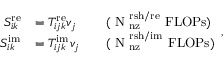<formula> <loc_0><loc_0><loc_500><loc_500>\begin{array} { r l r l } { S _ { i k } ^ { r e } } & { = T _ { i j k } ^ { r e } v _ { j } } & & { ( N _ { \mathrm } { n z } ^ { \mathrm } { r s h / r e } F L O P s ) } \\ { S _ { i k } ^ { i m } } & { = T _ { i j k } ^ { i m } v _ { j } } & & { ( N _ { \mathrm } { n z } ^ { \mathrm } { r s h / i m } F L O P s ) } \end{array} ,</formula> 